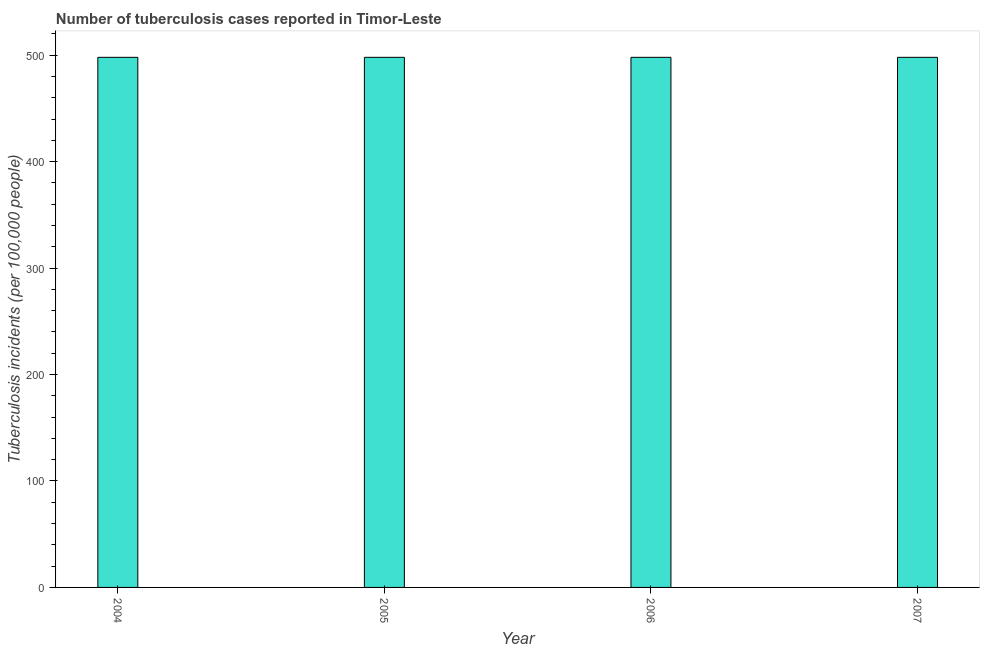Does the graph contain any zero values?
Provide a succinct answer. No. What is the title of the graph?
Offer a terse response. Number of tuberculosis cases reported in Timor-Leste. What is the label or title of the Y-axis?
Your answer should be compact. Tuberculosis incidents (per 100,0 people). What is the number of tuberculosis incidents in 2006?
Provide a succinct answer. 498. Across all years, what is the maximum number of tuberculosis incidents?
Provide a short and direct response. 498. Across all years, what is the minimum number of tuberculosis incidents?
Provide a short and direct response. 498. In which year was the number of tuberculosis incidents maximum?
Make the answer very short. 2004. What is the sum of the number of tuberculosis incidents?
Give a very brief answer. 1992. What is the difference between the number of tuberculosis incidents in 2004 and 2007?
Give a very brief answer. 0. What is the average number of tuberculosis incidents per year?
Provide a succinct answer. 498. What is the median number of tuberculosis incidents?
Provide a succinct answer. 498. Do a majority of the years between 2006 and 2004 (inclusive) have number of tuberculosis incidents greater than 80 ?
Offer a very short reply. Yes. What is the ratio of the number of tuberculosis incidents in 2004 to that in 2007?
Keep it short and to the point. 1. What is the difference between the highest and the second highest number of tuberculosis incidents?
Make the answer very short. 0. What is the difference between the highest and the lowest number of tuberculosis incidents?
Provide a short and direct response. 0. Are all the bars in the graph horizontal?
Your response must be concise. No. How many years are there in the graph?
Offer a terse response. 4. Are the values on the major ticks of Y-axis written in scientific E-notation?
Offer a very short reply. No. What is the Tuberculosis incidents (per 100,000 people) in 2004?
Give a very brief answer. 498. What is the Tuberculosis incidents (per 100,000 people) of 2005?
Keep it short and to the point. 498. What is the Tuberculosis incidents (per 100,000 people) in 2006?
Ensure brevity in your answer.  498. What is the Tuberculosis incidents (per 100,000 people) in 2007?
Keep it short and to the point. 498. What is the difference between the Tuberculosis incidents (per 100,000 people) in 2004 and 2007?
Provide a succinct answer. 0. What is the difference between the Tuberculosis incidents (per 100,000 people) in 2006 and 2007?
Offer a very short reply. 0. What is the ratio of the Tuberculosis incidents (per 100,000 people) in 2004 to that in 2006?
Provide a succinct answer. 1. What is the ratio of the Tuberculosis incidents (per 100,000 people) in 2004 to that in 2007?
Offer a very short reply. 1. What is the ratio of the Tuberculosis incidents (per 100,000 people) in 2005 to that in 2006?
Provide a short and direct response. 1. What is the ratio of the Tuberculosis incidents (per 100,000 people) in 2005 to that in 2007?
Your answer should be compact. 1. What is the ratio of the Tuberculosis incidents (per 100,000 people) in 2006 to that in 2007?
Ensure brevity in your answer.  1. 